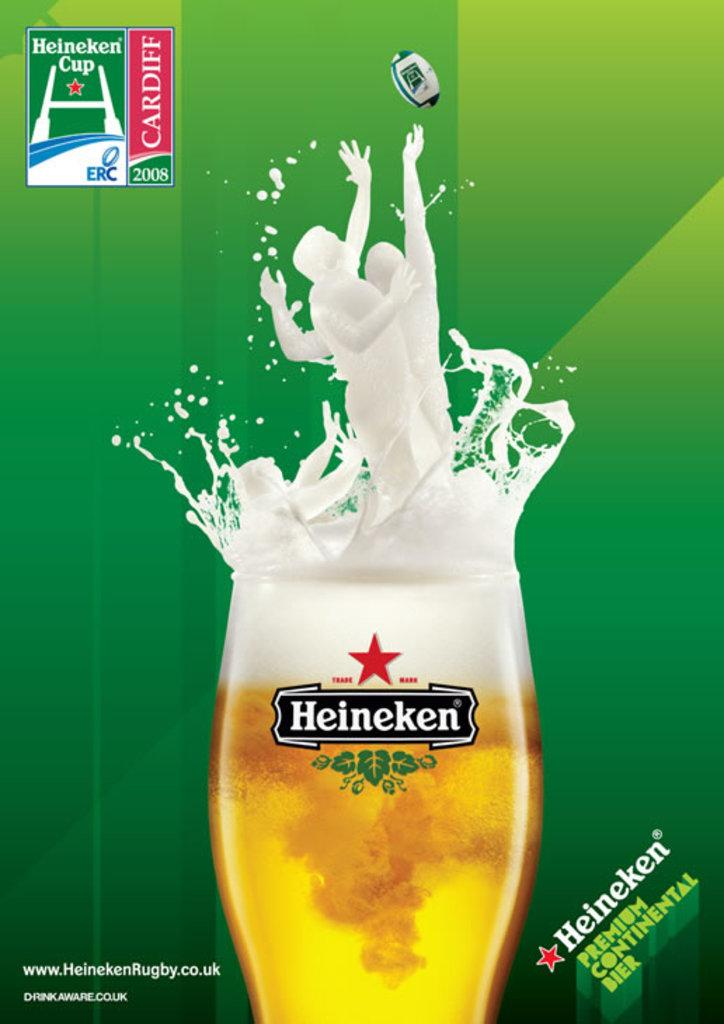<image>
Summarize the visual content of the image. an advertisement for Heineken and the Heineken Cup 